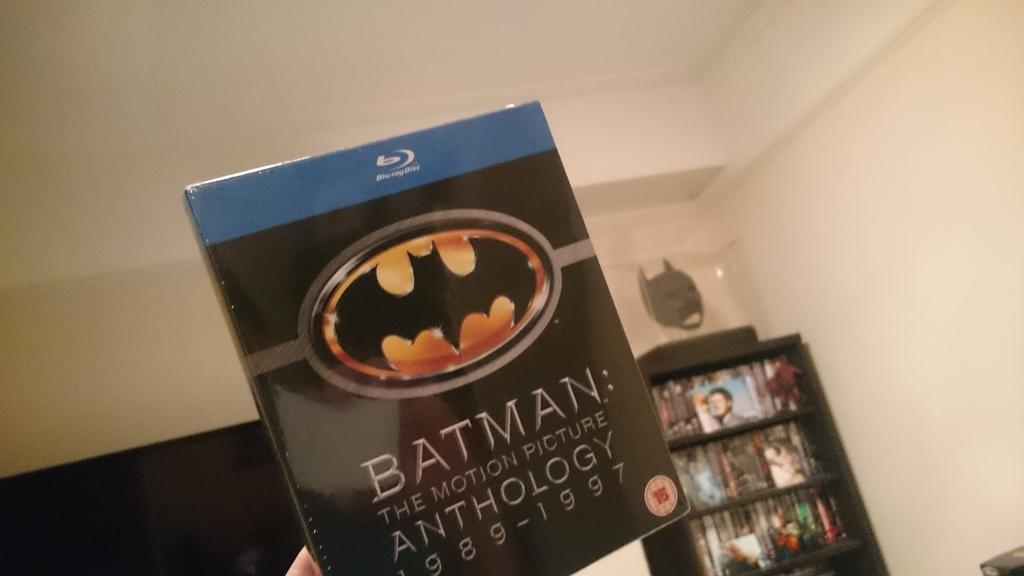<image>
Describe the image concisely. A Blu-ray case for Batman, the motion picture anthology 1989-1997. 